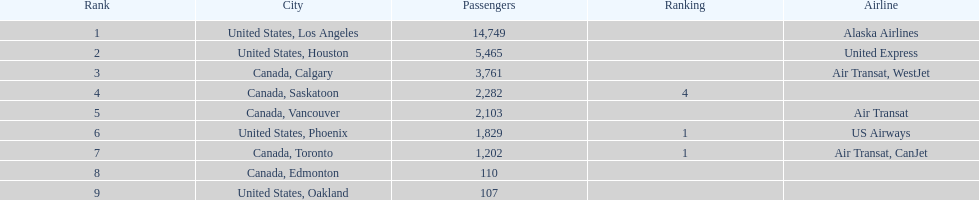How does the passenger count vary between los angeles and toronto? 13,547. 